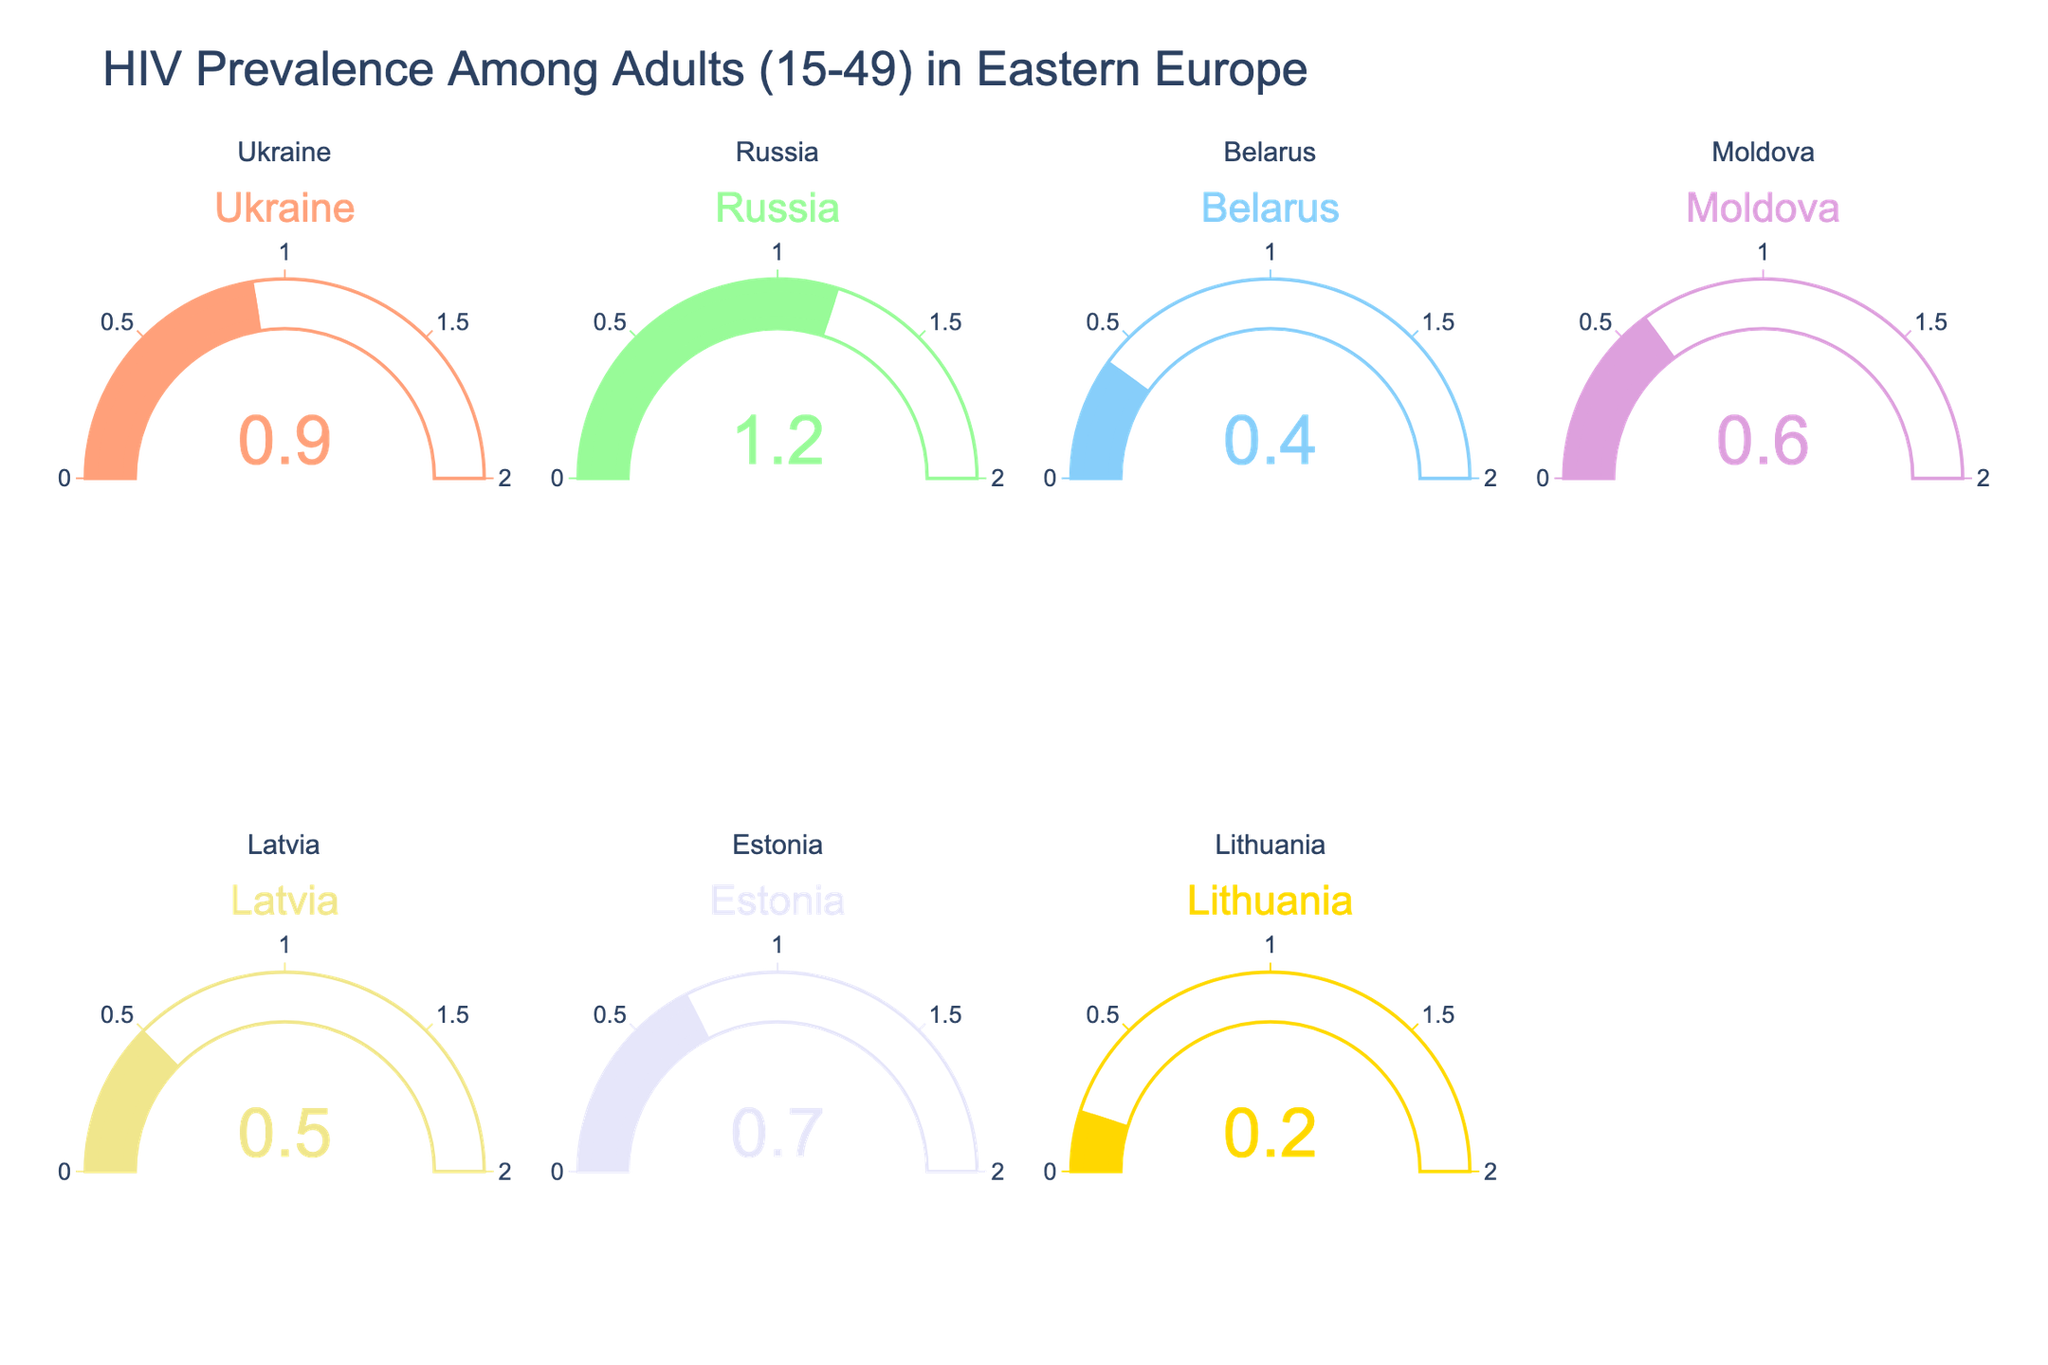How many countries are represented in the gauge charts? There are 2 rows and 4 columns of subplots, giving a total of 8 possible subplots, but only 7 are occupied based on the given data. Each subplot represents a country.
Answer: 7 What's the HIV prevalence of Belarus among adults aged 15-49? Locate the gauge chart for Belarus and read the number displayed.
Answer: 0.4 Which country has the highest HIV prevalence among adults aged 15-49? Compare the HIV prevalence values on all gauge charts. The highest is 1.2.
Answer: Russia How much higher is the HIV prevalence in Russia compared to Latvia? Find the values for Russia (1.2) and Latvia (0.5) and subtract the smaller value from the larger one: 1.2 - 0.5.
Answer: 0.7 What’s the average HIV prevalence among Estonia, Latvia, and Lithuania? Add the HIV prevalence values for Estonia (0.7), Latvia (0.5), and Lithuania (0.2) and divide by the number of countries (3): (0.7 + 0.5 + 0.2) / 3.
Answer: 0.467 Which country has the lowest HIV prevalence among adults aged 15-49? Compare the HIV prevalence values on all gauge charts. The lowest is 0.2.
Answer: Lithuania What is the total HIV prevalence value when combining Ukraine and Moldova? Add the HIV prevalence values for Ukraine (0.9) and Moldova (0.6): 0.9 + 0.6.
Answer: 1.5 What is the difference in HIV prevalence between Estonia and Belarus? Find the values for Estonia (0.7) and Belarus (0.4) and subtract the smaller value from the larger one: 0.7 - 0.4.
Answer: 0.3 Which countries have an HIV prevalence of less than 0.5 among adults aged 15-49? Identify countries with HIV prevalence values below 0.5.
Answer: Belarus, Lithuania Where is the visual title of the entire gauge chart figure located? The title "HIV Prevalence Among Adults (15-49) in Eastern Europe" is typically found at the top of the figure.
Answer: At the top 